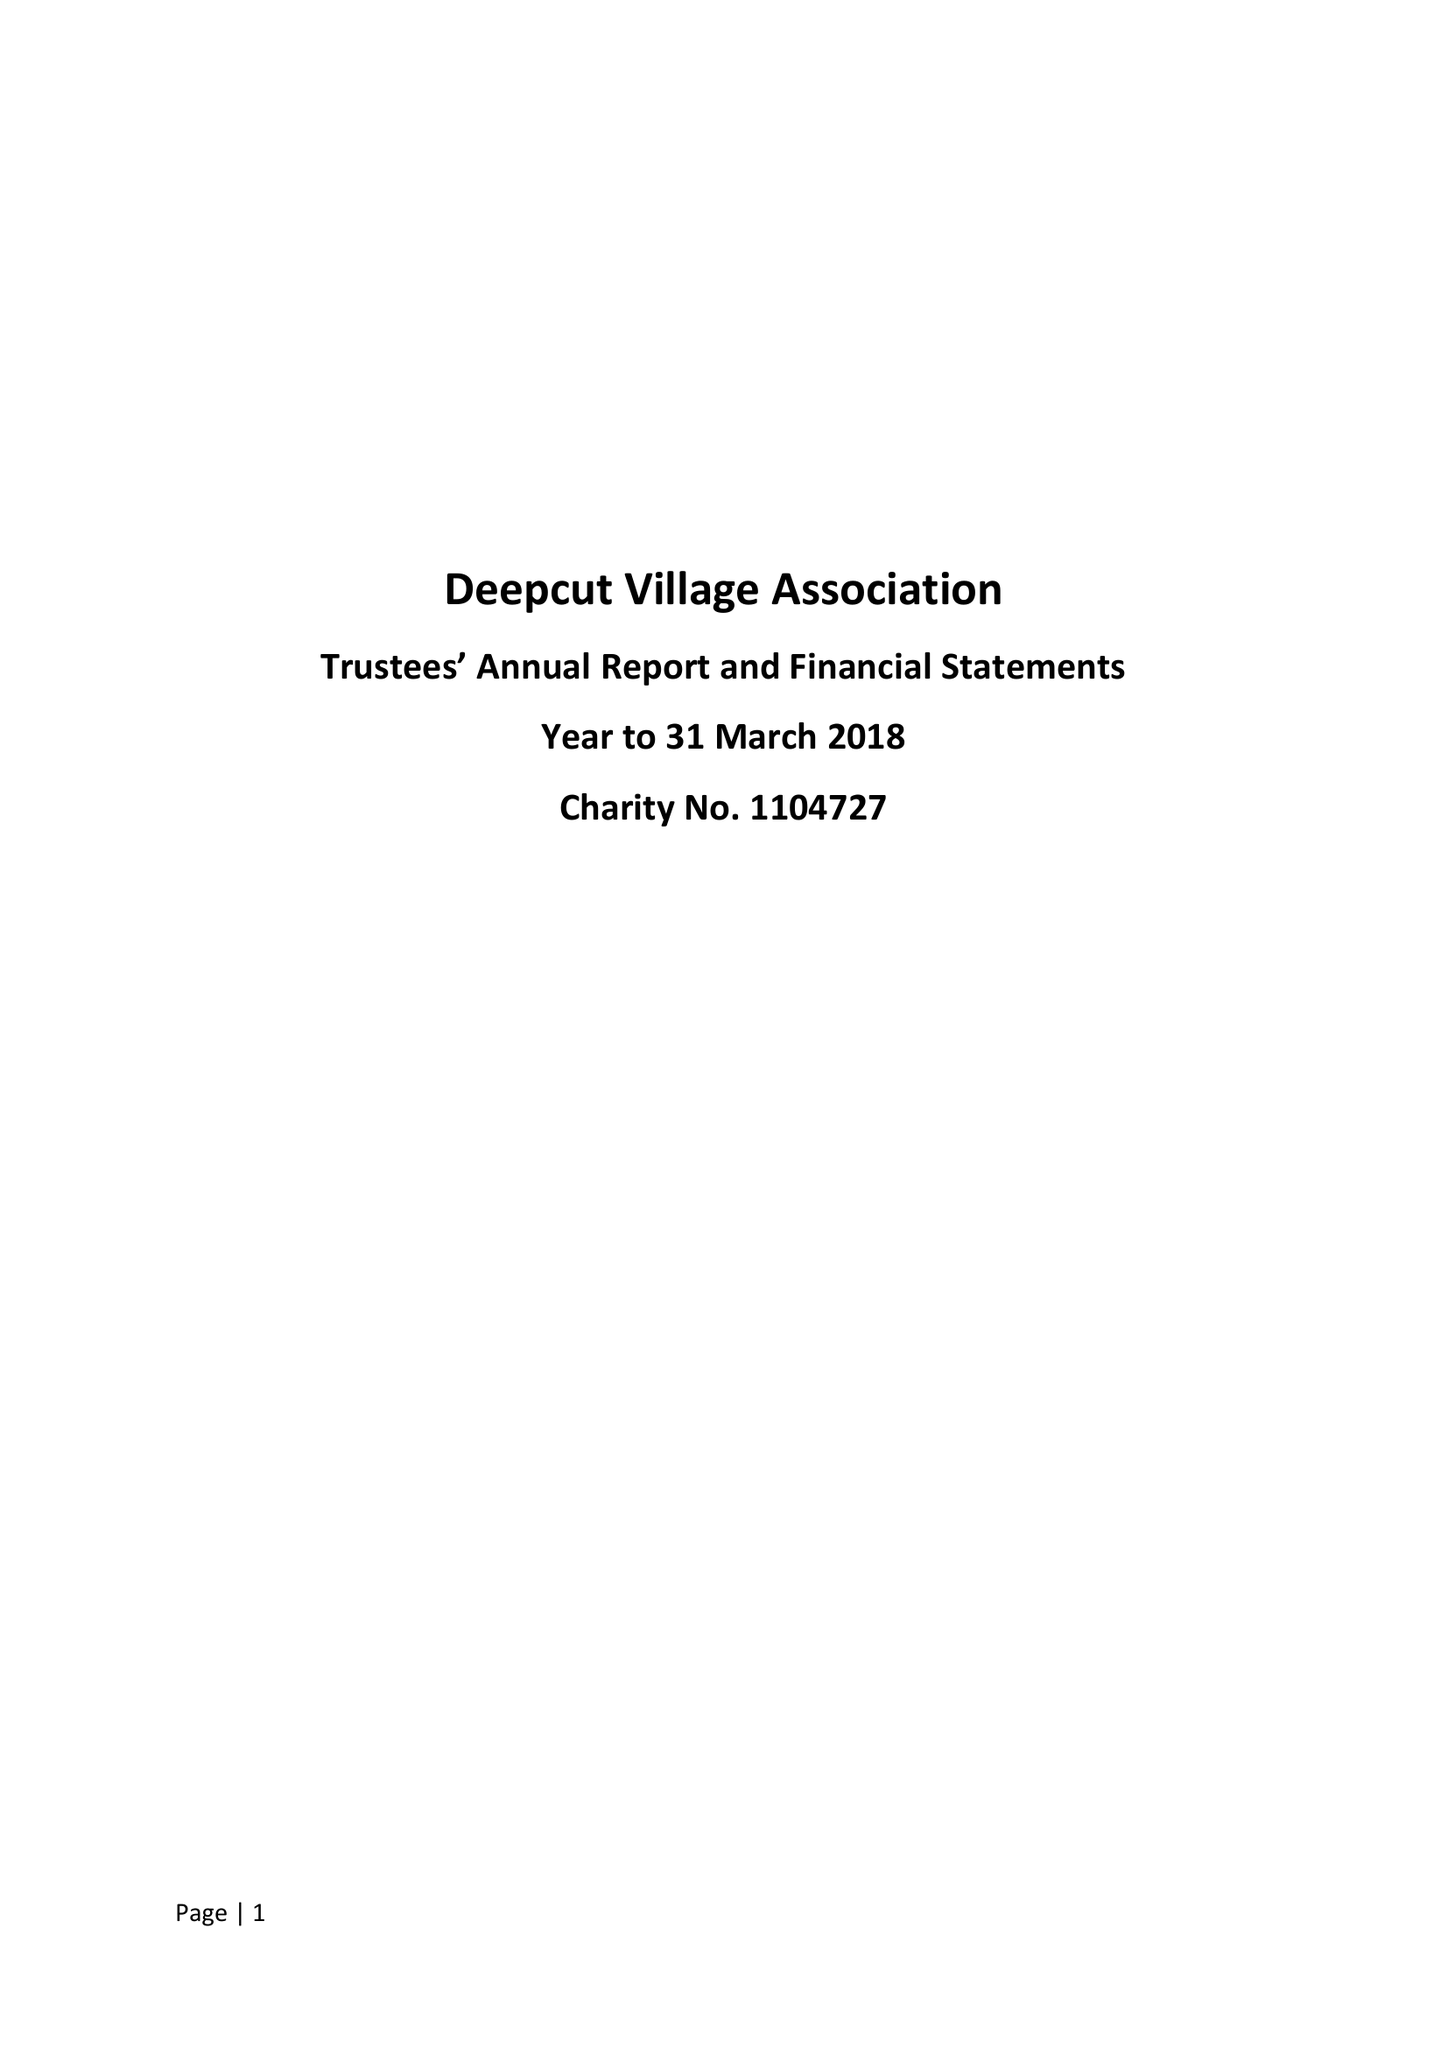What is the value for the report_date?
Answer the question using a single word or phrase. 2018-03-31 